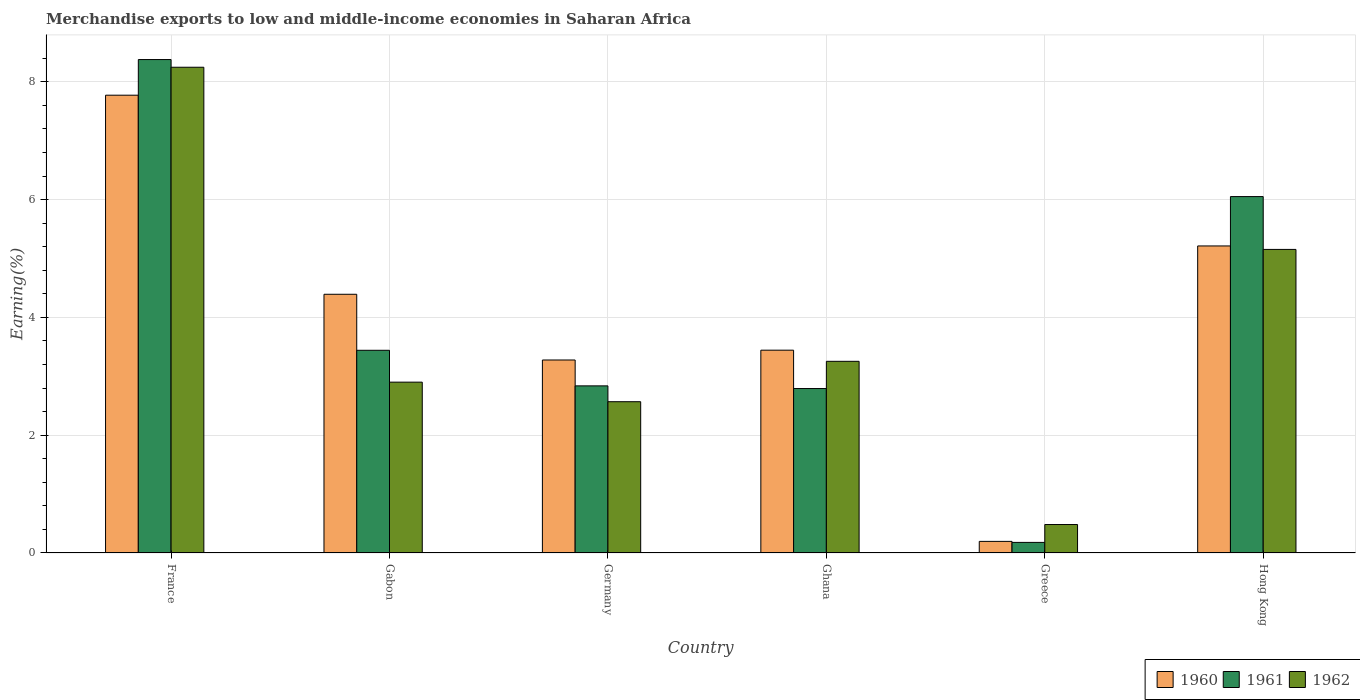How many groups of bars are there?
Provide a short and direct response. 6. Are the number of bars per tick equal to the number of legend labels?
Give a very brief answer. Yes. What is the label of the 2nd group of bars from the left?
Ensure brevity in your answer.  Gabon. In how many cases, is the number of bars for a given country not equal to the number of legend labels?
Provide a succinct answer. 0. What is the percentage of amount earned from merchandise exports in 1960 in Greece?
Keep it short and to the point. 0.2. Across all countries, what is the maximum percentage of amount earned from merchandise exports in 1961?
Provide a succinct answer. 8.38. Across all countries, what is the minimum percentage of amount earned from merchandise exports in 1961?
Make the answer very short. 0.18. In which country was the percentage of amount earned from merchandise exports in 1960 maximum?
Ensure brevity in your answer.  France. In which country was the percentage of amount earned from merchandise exports in 1960 minimum?
Make the answer very short. Greece. What is the total percentage of amount earned from merchandise exports in 1962 in the graph?
Provide a short and direct response. 22.61. What is the difference between the percentage of amount earned from merchandise exports in 1961 in Germany and that in Ghana?
Your answer should be compact. 0.05. What is the difference between the percentage of amount earned from merchandise exports in 1960 in France and the percentage of amount earned from merchandise exports in 1961 in Ghana?
Provide a succinct answer. 4.98. What is the average percentage of amount earned from merchandise exports in 1960 per country?
Provide a short and direct response. 4.05. What is the difference between the percentage of amount earned from merchandise exports of/in 1961 and percentage of amount earned from merchandise exports of/in 1962 in Gabon?
Your response must be concise. 0.54. What is the ratio of the percentage of amount earned from merchandise exports in 1960 in France to that in Germany?
Ensure brevity in your answer.  2.37. What is the difference between the highest and the second highest percentage of amount earned from merchandise exports in 1961?
Your response must be concise. 4.94. What is the difference between the highest and the lowest percentage of amount earned from merchandise exports in 1961?
Offer a terse response. 8.2. In how many countries, is the percentage of amount earned from merchandise exports in 1962 greater than the average percentage of amount earned from merchandise exports in 1962 taken over all countries?
Your answer should be compact. 2. Is the sum of the percentage of amount earned from merchandise exports in 1960 in Gabon and Greece greater than the maximum percentage of amount earned from merchandise exports in 1962 across all countries?
Offer a terse response. No. What does the 3rd bar from the right in Ghana represents?
Give a very brief answer. 1960. How many countries are there in the graph?
Your response must be concise. 6. What is the difference between two consecutive major ticks on the Y-axis?
Offer a very short reply. 2. Does the graph contain any zero values?
Give a very brief answer. No. How are the legend labels stacked?
Ensure brevity in your answer.  Horizontal. What is the title of the graph?
Your answer should be compact. Merchandise exports to low and middle-income economies in Saharan Africa. Does "1972" appear as one of the legend labels in the graph?
Give a very brief answer. No. What is the label or title of the Y-axis?
Your answer should be very brief. Earning(%). What is the Earning(%) of 1960 in France?
Your response must be concise. 7.77. What is the Earning(%) in 1961 in France?
Offer a very short reply. 8.38. What is the Earning(%) in 1962 in France?
Provide a succinct answer. 8.25. What is the Earning(%) of 1960 in Gabon?
Your answer should be very brief. 4.39. What is the Earning(%) of 1961 in Gabon?
Ensure brevity in your answer.  3.44. What is the Earning(%) in 1962 in Gabon?
Offer a terse response. 2.9. What is the Earning(%) in 1960 in Germany?
Offer a terse response. 3.28. What is the Earning(%) in 1961 in Germany?
Keep it short and to the point. 2.84. What is the Earning(%) in 1962 in Germany?
Offer a very short reply. 2.57. What is the Earning(%) of 1960 in Ghana?
Offer a very short reply. 3.44. What is the Earning(%) in 1961 in Ghana?
Ensure brevity in your answer.  2.79. What is the Earning(%) of 1962 in Ghana?
Provide a short and direct response. 3.25. What is the Earning(%) in 1960 in Greece?
Your answer should be very brief. 0.2. What is the Earning(%) in 1961 in Greece?
Your response must be concise. 0.18. What is the Earning(%) of 1962 in Greece?
Provide a succinct answer. 0.48. What is the Earning(%) in 1960 in Hong Kong?
Your answer should be compact. 5.21. What is the Earning(%) of 1961 in Hong Kong?
Offer a very short reply. 6.05. What is the Earning(%) in 1962 in Hong Kong?
Your answer should be very brief. 5.16. Across all countries, what is the maximum Earning(%) of 1960?
Your answer should be compact. 7.77. Across all countries, what is the maximum Earning(%) of 1961?
Provide a short and direct response. 8.38. Across all countries, what is the maximum Earning(%) in 1962?
Your response must be concise. 8.25. Across all countries, what is the minimum Earning(%) in 1960?
Provide a short and direct response. 0.2. Across all countries, what is the minimum Earning(%) of 1961?
Keep it short and to the point. 0.18. Across all countries, what is the minimum Earning(%) of 1962?
Make the answer very short. 0.48. What is the total Earning(%) in 1960 in the graph?
Your answer should be very brief. 24.3. What is the total Earning(%) of 1961 in the graph?
Give a very brief answer. 23.68. What is the total Earning(%) of 1962 in the graph?
Provide a succinct answer. 22.61. What is the difference between the Earning(%) in 1960 in France and that in Gabon?
Offer a very short reply. 3.38. What is the difference between the Earning(%) of 1961 in France and that in Gabon?
Offer a terse response. 4.94. What is the difference between the Earning(%) in 1962 in France and that in Gabon?
Your response must be concise. 5.35. What is the difference between the Earning(%) in 1960 in France and that in Germany?
Offer a very short reply. 4.5. What is the difference between the Earning(%) of 1961 in France and that in Germany?
Give a very brief answer. 5.54. What is the difference between the Earning(%) of 1962 in France and that in Germany?
Provide a short and direct response. 5.68. What is the difference between the Earning(%) of 1960 in France and that in Ghana?
Give a very brief answer. 4.33. What is the difference between the Earning(%) in 1961 in France and that in Ghana?
Provide a short and direct response. 5.59. What is the difference between the Earning(%) in 1962 in France and that in Ghana?
Make the answer very short. 4.99. What is the difference between the Earning(%) of 1960 in France and that in Greece?
Make the answer very short. 7.58. What is the difference between the Earning(%) of 1961 in France and that in Greece?
Keep it short and to the point. 8.2. What is the difference between the Earning(%) of 1962 in France and that in Greece?
Make the answer very short. 7.77. What is the difference between the Earning(%) of 1960 in France and that in Hong Kong?
Your answer should be very brief. 2.56. What is the difference between the Earning(%) of 1961 in France and that in Hong Kong?
Your answer should be compact. 2.33. What is the difference between the Earning(%) in 1962 in France and that in Hong Kong?
Keep it short and to the point. 3.09. What is the difference between the Earning(%) in 1960 in Gabon and that in Germany?
Give a very brief answer. 1.12. What is the difference between the Earning(%) of 1961 in Gabon and that in Germany?
Your answer should be compact. 0.6. What is the difference between the Earning(%) of 1962 in Gabon and that in Germany?
Offer a terse response. 0.33. What is the difference between the Earning(%) of 1960 in Gabon and that in Ghana?
Provide a succinct answer. 0.95. What is the difference between the Earning(%) of 1961 in Gabon and that in Ghana?
Give a very brief answer. 0.65. What is the difference between the Earning(%) of 1962 in Gabon and that in Ghana?
Give a very brief answer. -0.35. What is the difference between the Earning(%) in 1960 in Gabon and that in Greece?
Make the answer very short. 4.2. What is the difference between the Earning(%) in 1961 in Gabon and that in Greece?
Provide a short and direct response. 3.26. What is the difference between the Earning(%) in 1962 in Gabon and that in Greece?
Your answer should be compact. 2.42. What is the difference between the Earning(%) in 1960 in Gabon and that in Hong Kong?
Give a very brief answer. -0.82. What is the difference between the Earning(%) of 1961 in Gabon and that in Hong Kong?
Make the answer very short. -2.61. What is the difference between the Earning(%) of 1962 in Gabon and that in Hong Kong?
Provide a succinct answer. -2.25. What is the difference between the Earning(%) in 1960 in Germany and that in Ghana?
Your response must be concise. -0.17. What is the difference between the Earning(%) in 1961 in Germany and that in Ghana?
Your answer should be very brief. 0.05. What is the difference between the Earning(%) of 1962 in Germany and that in Ghana?
Make the answer very short. -0.69. What is the difference between the Earning(%) of 1960 in Germany and that in Greece?
Your answer should be compact. 3.08. What is the difference between the Earning(%) in 1961 in Germany and that in Greece?
Your answer should be very brief. 2.66. What is the difference between the Earning(%) of 1962 in Germany and that in Greece?
Offer a very short reply. 2.09. What is the difference between the Earning(%) in 1960 in Germany and that in Hong Kong?
Give a very brief answer. -1.94. What is the difference between the Earning(%) of 1961 in Germany and that in Hong Kong?
Ensure brevity in your answer.  -3.21. What is the difference between the Earning(%) in 1962 in Germany and that in Hong Kong?
Offer a very short reply. -2.59. What is the difference between the Earning(%) of 1960 in Ghana and that in Greece?
Ensure brevity in your answer.  3.25. What is the difference between the Earning(%) of 1961 in Ghana and that in Greece?
Give a very brief answer. 2.61. What is the difference between the Earning(%) of 1962 in Ghana and that in Greece?
Offer a very short reply. 2.77. What is the difference between the Earning(%) in 1960 in Ghana and that in Hong Kong?
Provide a short and direct response. -1.77. What is the difference between the Earning(%) of 1961 in Ghana and that in Hong Kong?
Offer a very short reply. -3.26. What is the difference between the Earning(%) in 1962 in Ghana and that in Hong Kong?
Ensure brevity in your answer.  -1.9. What is the difference between the Earning(%) in 1960 in Greece and that in Hong Kong?
Your response must be concise. -5.02. What is the difference between the Earning(%) of 1961 in Greece and that in Hong Kong?
Offer a terse response. -5.87. What is the difference between the Earning(%) of 1962 in Greece and that in Hong Kong?
Give a very brief answer. -4.67. What is the difference between the Earning(%) of 1960 in France and the Earning(%) of 1961 in Gabon?
Give a very brief answer. 4.33. What is the difference between the Earning(%) in 1960 in France and the Earning(%) in 1962 in Gabon?
Your response must be concise. 4.87. What is the difference between the Earning(%) in 1961 in France and the Earning(%) in 1962 in Gabon?
Offer a very short reply. 5.48. What is the difference between the Earning(%) of 1960 in France and the Earning(%) of 1961 in Germany?
Keep it short and to the point. 4.94. What is the difference between the Earning(%) of 1960 in France and the Earning(%) of 1962 in Germany?
Provide a short and direct response. 5.21. What is the difference between the Earning(%) in 1961 in France and the Earning(%) in 1962 in Germany?
Give a very brief answer. 5.81. What is the difference between the Earning(%) of 1960 in France and the Earning(%) of 1961 in Ghana?
Your response must be concise. 4.98. What is the difference between the Earning(%) in 1960 in France and the Earning(%) in 1962 in Ghana?
Provide a succinct answer. 4.52. What is the difference between the Earning(%) in 1961 in France and the Earning(%) in 1962 in Ghana?
Ensure brevity in your answer.  5.12. What is the difference between the Earning(%) of 1960 in France and the Earning(%) of 1961 in Greece?
Your response must be concise. 7.59. What is the difference between the Earning(%) in 1960 in France and the Earning(%) in 1962 in Greece?
Keep it short and to the point. 7.29. What is the difference between the Earning(%) in 1961 in France and the Earning(%) in 1962 in Greece?
Give a very brief answer. 7.9. What is the difference between the Earning(%) of 1960 in France and the Earning(%) of 1961 in Hong Kong?
Give a very brief answer. 1.72. What is the difference between the Earning(%) in 1960 in France and the Earning(%) in 1962 in Hong Kong?
Your answer should be compact. 2.62. What is the difference between the Earning(%) in 1961 in France and the Earning(%) in 1962 in Hong Kong?
Ensure brevity in your answer.  3.22. What is the difference between the Earning(%) in 1960 in Gabon and the Earning(%) in 1961 in Germany?
Your answer should be very brief. 1.56. What is the difference between the Earning(%) of 1960 in Gabon and the Earning(%) of 1962 in Germany?
Provide a succinct answer. 1.82. What is the difference between the Earning(%) of 1961 in Gabon and the Earning(%) of 1962 in Germany?
Ensure brevity in your answer.  0.87. What is the difference between the Earning(%) in 1960 in Gabon and the Earning(%) in 1961 in Ghana?
Give a very brief answer. 1.6. What is the difference between the Earning(%) in 1960 in Gabon and the Earning(%) in 1962 in Ghana?
Offer a terse response. 1.14. What is the difference between the Earning(%) of 1961 in Gabon and the Earning(%) of 1962 in Ghana?
Make the answer very short. 0.19. What is the difference between the Earning(%) of 1960 in Gabon and the Earning(%) of 1961 in Greece?
Your answer should be very brief. 4.21. What is the difference between the Earning(%) in 1960 in Gabon and the Earning(%) in 1962 in Greece?
Ensure brevity in your answer.  3.91. What is the difference between the Earning(%) of 1961 in Gabon and the Earning(%) of 1962 in Greece?
Provide a short and direct response. 2.96. What is the difference between the Earning(%) of 1960 in Gabon and the Earning(%) of 1961 in Hong Kong?
Your answer should be very brief. -1.66. What is the difference between the Earning(%) in 1960 in Gabon and the Earning(%) in 1962 in Hong Kong?
Your response must be concise. -0.76. What is the difference between the Earning(%) in 1961 in Gabon and the Earning(%) in 1962 in Hong Kong?
Ensure brevity in your answer.  -1.71. What is the difference between the Earning(%) in 1960 in Germany and the Earning(%) in 1961 in Ghana?
Your answer should be compact. 0.48. What is the difference between the Earning(%) of 1960 in Germany and the Earning(%) of 1962 in Ghana?
Offer a very short reply. 0.02. What is the difference between the Earning(%) in 1961 in Germany and the Earning(%) in 1962 in Ghana?
Provide a short and direct response. -0.42. What is the difference between the Earning(%) in 1960 in Germany and the Earning(%) in 1961 in Greece?
Provide a short and direct response. 3.1. What is the difference between the Earning(%) in 1960 in Germany and the Earning(%) in 1962 in Greece?
Provide a succinct answer. 2.79. What is the difference between the Earning(%) of 1961 in Germany and the Earning(%) of 1962 in Greece?
Provide a succinct answer. 2.35. What is the difference between the Earning(%) of 1960 in Germany and the Earning(%) of 1961 in Hong Kong?
Provide a succinct answer. -2.77. What is the difference between the Earning(%) in 1960 in Germany and the Earning(%) in 1962 in Hong Kong?
Keep it short and to the point. -1.88. What is the difference between the Earning(%) of 1961 in Germany and the Earning(%) of 1962 in Hong Kong?
Ensure brevity in your answer.  -2.32. What is the difference between the Earning(%) of 1960 in Ghana and the Earning(%) of 1961 in Greece?
Your response must be concise. 3.26. What is the difference between the Earning(%) in 1960 in Ghana and the Earning(%) in 1962 in Greece?
Give a very brief answer. 2.96. What is the difference between the Earning(%) in 1961 in Ghana and the Earning(%) in 1962 in Greece?
Offer a very short reply. 2.31. What is the difference between the Earning(%) in 1960 in Ghana and the Earning(%) in 1961 in Hong Kong?
Ensure brevity in your answer.  -2.61. What is the difference between the Earning(%) in 1960 in Ghana and the Earning(%) in 1962 in Hong Kong?
Offer a terse response. -1.71. What is the difference between the Earning(%) in 1961 in Ghana and the Earning(%) in 1962 in Hong Kong?
Offer a very short reply. -2.36. What is the difference between the Earning(%) in 1960 in Greece and the Earning(%) in 1961 in Hong Kong?
Provide a short and direct response. -5.86. What is the difference between the Earning(%) of 1960 in Greece and the Earning(%) of 1962 in Hong Kong?
Make the answer very short. -4.96. What is the difference between the Earning(%) in 1961 in Greece and the Earning(%) in 1962 in Hong Kong?
Your answer should be compact. -4.98. What is the average Earning(%) in 1960 per country?
Your answer should be very brief. 4.05. What is the average Earning(%) in 1961 per country?
Provide a short and direct response. 3.95. What is the average Earning(%) in 1962 per country?
Offer a very short reply. 3.77. What is the difference between the Earning(%) of 1960 and Earning(%) of 1961 in France?
Offer a terse response. -0.61. What is the difference between the Earning(%) in 1960 and Earning(%) in 1962 in France?
Ensure brevity in your answer.  -0.47. What is the difference between the Earning(%) in 1961 and Earning(%) in 1962 in France?
Your response must be concise. 0.13. What is the difference between the Earning(%) in 1960 and Earning(%) in 1961 in Gabon?
Provide a short and direct response. 0.95. What is the difference between the Earning(%) in 1960 and Earning(%) in 1962 in Gabon?
Your answer should be compact. 1.49. What is the difference between the Earning(%) of 1961 and Earning(%) of 1962 in Gabon?
Provide a succinct answer. 0.54. What is the difference between the Earning(%) of 1960 and Earning(%) of 1961 in Germany?
Your answer should be compact. 0.44. What is the difference between the Earning(%) in 1960 and Earning(%) in 1962 in Germany?
Make the answer very short. 0.71. What is the difference between the Earning(%) of 1961 and Earning(%) of 1962 in Germany?
Keep it short and to the point. 0.27. What is the difference between the Earning(%) of 1960 and Earning(%) of 1961 in Ghana?
Ensure brevity in your answer.  0.65. What is the difference between the Earning(%) in 1960 and Earning(%) in 1962 in Ghana?
Ensure brevity in your answer.  0.19. What is the difference between the Earning(%) in 1961 and Earning(%) in 1962 in Ghana?
Ensure brevity in your answer.  -0.46. What is the difference between the Earning(%) in 1960 and Earning(%) in 1961 in Greece?
Ensure brevity in your answer.  0.02. What is the difference between the Earning(%) of 1960 and Earning(%) of 1962 in Greece?
Make the answer very short. -0.29. What is the difference between the Earning(%) in 1961 and Earning(%) in 1962 in Greece?
Your response must be concise. -0.3. What is the difference between the Earning(%) of 1960 and Earning(%) of 1961 in Hong Kong?
Your response must be concise. -0.84. What is the difference between the Earning(%) of 1960 and Earning(%) of 1962 in Hong Kong?
Keep it short and to the point. 0.06. What is the difference between the Earning(%) of 1961 and Earning(%) of 1962 in Hong Kong?
Provide a succinct answer. 0.9. What is the ratio of the Earning(%) of 1960 in France to that in Gabon?
Offer a very short reply. 1.77. What is the ratio of the Earning(%) of 1961 in France to that in Gabon?
Your response must be concise. 2.43. What is the ratio of the Earning(%) in 1962 in France to that in Gabon?
Provide a succinct answer. 2.84. What is the ratio of the Earning(%) of 1960 in France to that in Germany?
Give a very brief answer. 2.37. What is the ratio of the Earning(%) in 1961 in France to that in Germany?
Offer a terse response. 2.95. What is the ratio of the Earning(%) in 1962 in France to that in Germany?
Ensure brevity in your answer.  3.21. What is the ratio of the Earning(%) in 1960 in France to that in Ghana?
Your answer should be compact. 2.26. What is the ratio of the Earning(%) in 1961 in France to that in Ghana?
Give a very brief answer. 3. What is the ratio of the Earning(%) in 1962 in France to that in Ghana?
Make the answer very short. 2.53. What is the ratio of the Earning(%) of 1960 in France to that in Greece?
Provide a succinct answer. 39.47. What is the ratio of the Earning(%) in 1961 in France to that in Greece?
Give a very brief answer. 46.61. What is the ratio of the Earning(%) in 1962 in France to that in Greece?
Provide a succinct answer. 17.07. What is the ratio of the Earning(%) in 1960 in France to that in Hong Kong?
Offer a terse response. 1.49. What is the ratio of the Earning(%) in 1961 in France to that in Hong Kong?
Offer a very short reply. 1.38. What is the ratio of the Earning(%) of 1962 in France to that in Hong Kong?
Ensure brevity in your answer.  1.6. What is the ratio of the Earning(%) in 1960 in Gabon to that in Germany?
Provide a succinct answer. 1.34. What is the ratio of the Earning(%) in 1961 in Gabon to that in Germany?
Offer a terse response. 1.21. What is the ratio of the Earning(%) in 1962 in Gabon to that in Germany?
Ensure brevity in your answer.  1.13. What is the ratio of the Earning(%) of 1960 in Gabon to that in Ghana?
Make the answer very short. 1.28. What is the ratio of the Earning(%) of 1961 in Gabon to that in Ghana?
Keep it short and to the point. 1.23. What is the ratio of the Earning(%) in 1962 in Gabon to that in Ghana?
Make the answer very short. 0.89. What is the ratio of the Earning(%) in 1960 in Gabon to that in Greece?
Ensure brevity in your answer.  22.31. What is the ratio of the Earning(%) of 1961 in Gabon to that in Greece?
Keep it short and to the point. 19.15. What is the ratio of the Earning(%) in 1962 in Gabon to that in Greece?
Your answer should be compact. 6. What is the ratio of the Earning(%) in 1960 in Gabon to that in Hong Kong?
Your answer should be compact. 0.84. What is the ratio of the Earning(%) of 1961 in Gabon to that in Hong Kong?
Provide a short and direct response. 0.57. What is the ratio of the Earning(%) in 1962 in Gabon to that in Hong Kong?
Provide a short and direct response. 0.56. What is the ratio of the Earning(%) of 1960 in Germany to that in Ghana?
Provide a succinct answer. 0.95. What is the ratio of the Earning(%) of 1961 in Germany to that in Ghana?
Provide a short and direct response. 1.02. What is the ratio of the Earning(%) of 1962 in Germany to that in Ghana?
Provide a short and direct response. 0.79. What is the ratio of the Earning(%) in 1960 in Germany to that in Greece?
Your answer should be compact. 16.64. What is the ratio of the Earning(%) in 1961 in Germany to that in Greece?
Provide a short and direct response. 15.79. What is the ratio of the Earning(%) of 1962 in Germany to that in Greece?
Provide a succinct answer. 5.32. What is the ratio of the Earning(%) in 1960 in Germany to that in Hong Kong?
Ensure brevity in your answer.  0.63. What is the ratio of the Earning(%) of 1961 in Germany to that in Hong Kong?
Your answer should be very brief. 0.47. What is the ratio of the Earning(%) of 1962 in Germany to that in Hong Kong?
Provide a succinct answer. 0.5. What is the ratio of the Earning(%) of 1960 in Ghana to that in Greece?
Your answer should be very brief. 17.49. What is the ratio of the Earning(%) in 1961 in Ghana to that in Greece?
Provide a succinct answer. 15.53. What is the ratio of the Earning(%) in 1962 in Ghana to that in Greece?
Offer a terse response. 6.73. What is the ratio of the Earning(%) of 1960 in Ghana to that in Hong Kong?
Your response must be concise. 0.66. What is the ratio of the Earning(%) of 1961 in Ghana to that in Hong Kong?
Offer a very short reply. 0.46. What is the ratio of the Earning(%) of 1962 in Ghana to that in Hong Kong?
Give a very brief answer. 0.63. What is the ratio of the Earning(%) of 1960 in Greece to that in Hong Kong?
Your answer should be very brief. 0.04. What is the ratio of the Earning(%) in 1961 in Greece to that in Hong Kong?
Offer a very short reply. 0.03. What is the ratio of the Earning(%) of 1962 in Greece to that in Hong Kong?
Provide a short and direct response. 0.09. What is the difference between the highest and the second highest Earning(%) of 1960?
Ensure brevity in your answer.  2.56. What is the difference between the highest and the second highest Earning(%) of 1961?
Offer a terse response. 2.33. What is the difference between the highest and the second highest Earning(%) of 1962?
Ensure brevity in your answer.  3.09. What is the difference between the highest and the lowest Earning(%) of 1960?
Offer a very short reply. 7.58. What is the difference between the highest and the lowest Earning(%) in 1961?
Provide a succinct answer. 8.2. What is the difference between the highest and the lowest Earning(%) in 1962?
Your answer should be compact. 7.77. 